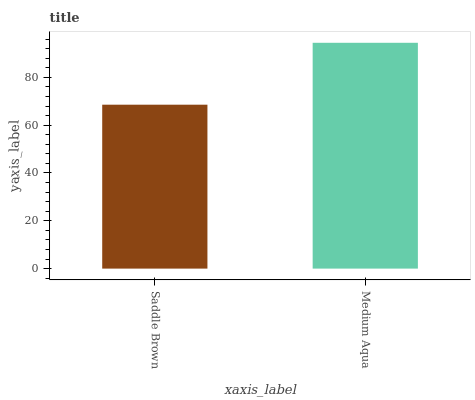Is Saddle Brown the minimum?
Answer yes or no. Yes. Is Medium Aqua the maximum?
Answer yes or no. Yes. Is Medium Aqua the minimum?
Answer yes or no. No. Is Medium Aqua greater than Saddle Brown?
Answer yes or no. Yes. Is Saddle Brown less than Medium Aqua?
Answer yes or no. Yes. Is Saddle Brown greater than Medium Aqua?
Answer yes or no. No. Is Medium Aqua less than Saddle Brown?
Answer yes or no. No. Is Medium Aqua the high median?
Answer yes or no. Yes. Is Saddle Brown the low median?
Answer yes or no. Yes. Is Saddle Brown the high median?
Answer yes or no. No. Is Medium Aqua the low median?
Answer yes or no. No. 